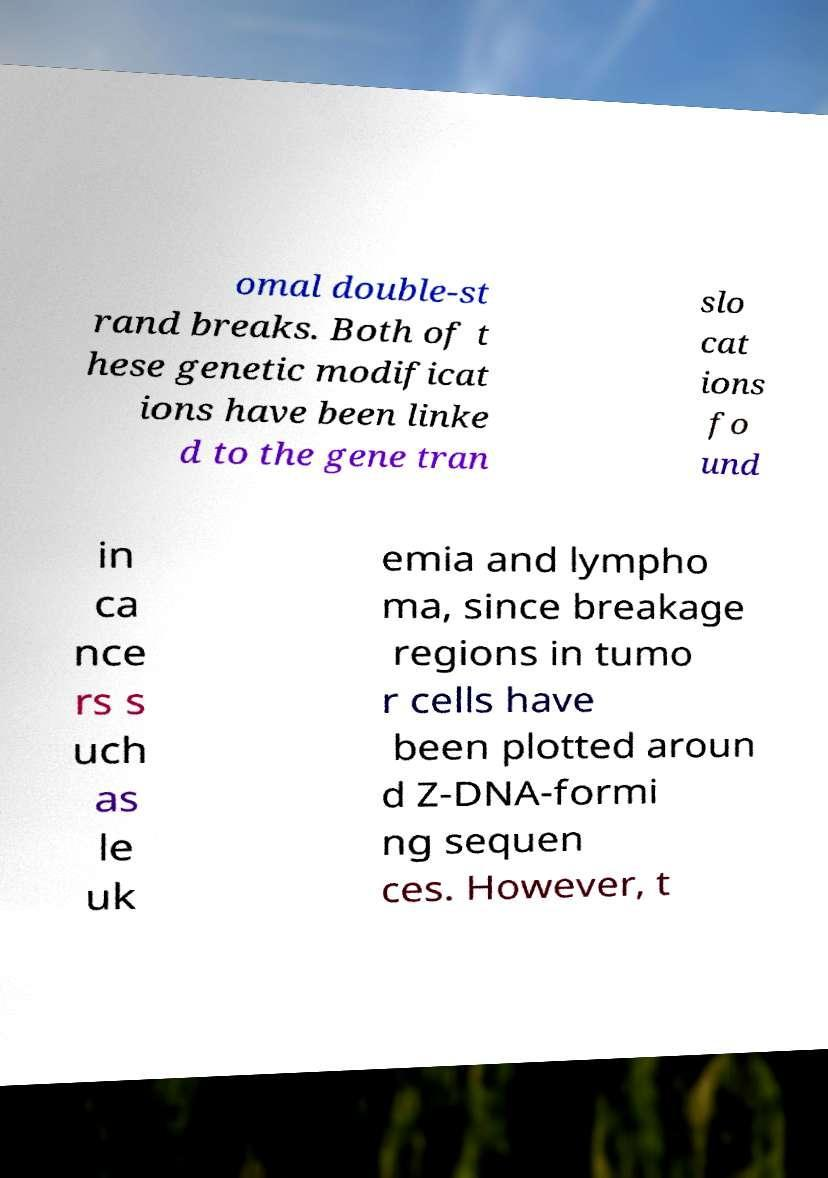Please read and relay the text visible in this image. What does it say? omal double-st rand breaks. Both of t hese genetic modificat ions have been linke d to the gene tran slo cat ions fo und in ca nce rs s uch as le uk emia and lympho ma, since breakage regions in tumo r cells have been plotted aroun d Z-DNA-formi ng sequen ces. However, t 